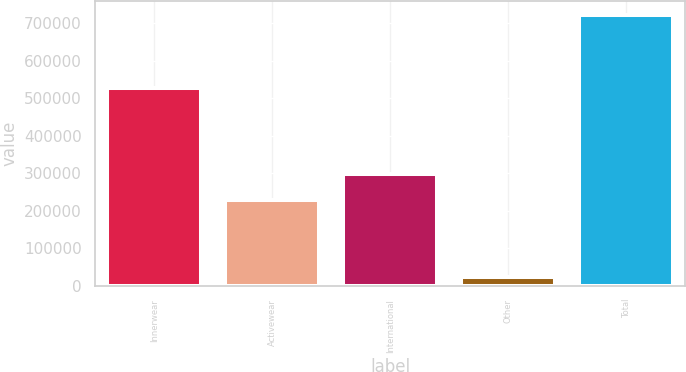<chart> <loc_0><loc_0><loc_500><loc_500><bar_chart><fcel>Innerwear<fcel>Activewear<fcel>International<fcel>Other<fcel>Total<nl><fcel>528038<fcel>227589<fcel>297559<fcel>23364<fcel>723068<nl></chart> 